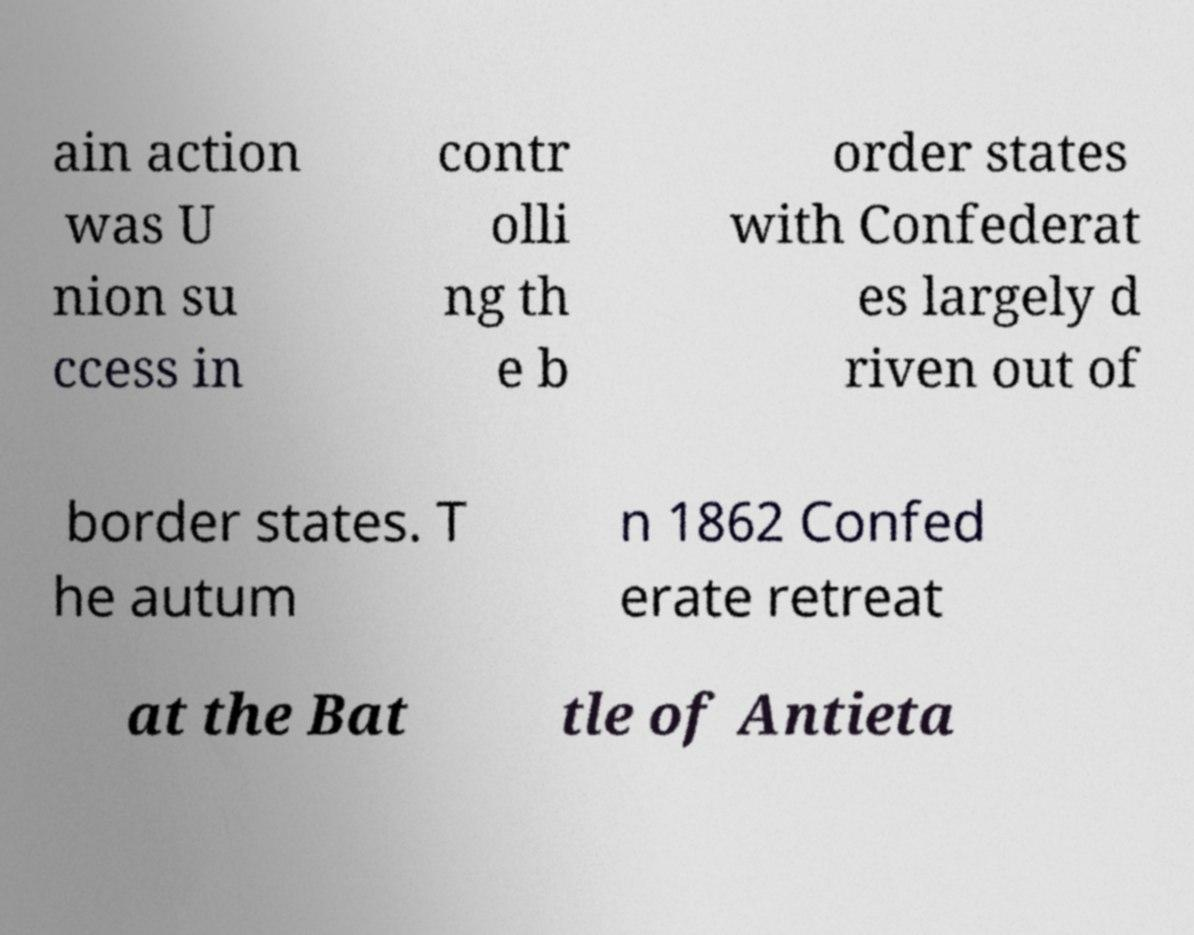Please identify and transcribe the text found in this image. ain action was U nion su ccess in contr olli ng th e b order states with Confederat es largely d riven out of border states. T he autum n 1862 Confed erate retreat at the Bat tle of Antieta 